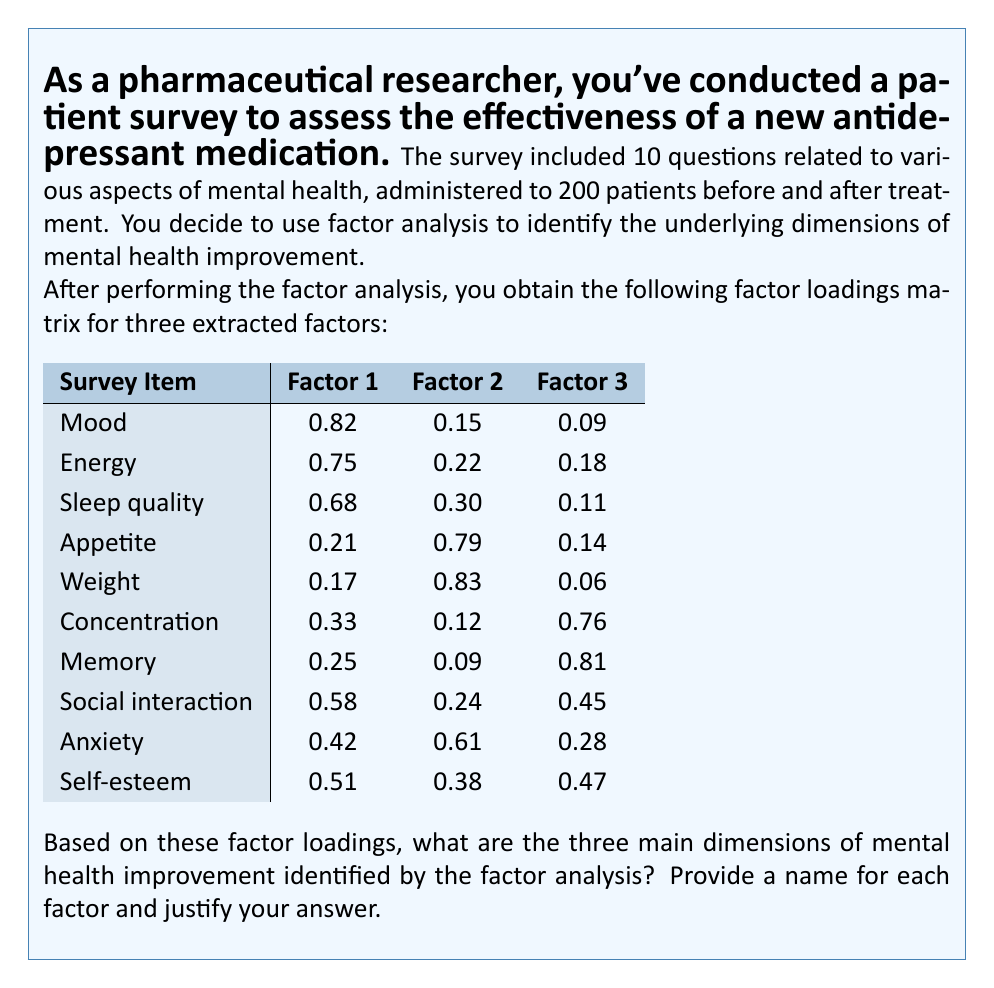Teach me how to tackle this problem. To identify the main dimensions of mental health improvement, we need to examine the factor loadings for each survey item across the three factors. We'll consider a loading of 0.6 or higher as significant for determining which items belong to each factor.

Step 1: Analyze Factor 1
- High loadings: Mood (0.82), Energy (0.75), Sleep quality (0.68)
- Moderate loading: Social interaction (0.58)
These items relate to overall emotional well-being and daily functioning. We can name this factor "Emotional and Physical Vitality."

Step 2: Analyze Factor 2
- High loadings: Appetite (0.79), Weight (0.83)
- Moderate loading: Anxiety (0.61)
These items are primarily related to physical symptoms often associated with depression and anxiety. We can name this factor "Physiological Regulation."

Step 3: Analyze Factor 3
- High loadings: Concentration (0.76), Memory (0.81)
These items are clearly related to cognitive function. We can name this factor "Cognitive Function."

Step 4: Consider cross-loadings and complex items
- Social interaction and Self-esteem have moderate loadings across multiple factors, indicating they may be influenced by multiple dimensions of mental health improvement.
- Anxiety loads moderately on Factor 2 but also has some loading on Factor 1, suggesting it's related to both physiological and emotional aspects.

Step 5: Summarize the findings
The three main dimensions of mental health improvement identified by the factor analysis are:
1. Emotional and Physical Vitality: Related to mood, energy, and sleep quality.
2. Physiological Regulation: Related to appetite, weight, and some aspects of anxiety.
3. Cognitive Function: Related to concentration and memory.

These dimensions provide insight into how the antidepressant medication affects different aspects of mental health, which can be valuable for understanding its overall effectiveness and potential areas for further development or targeted interventions.
Answer: 1. Emotional and Physical Vitality
2. Physiological Regulation
3. Cognitive Function 